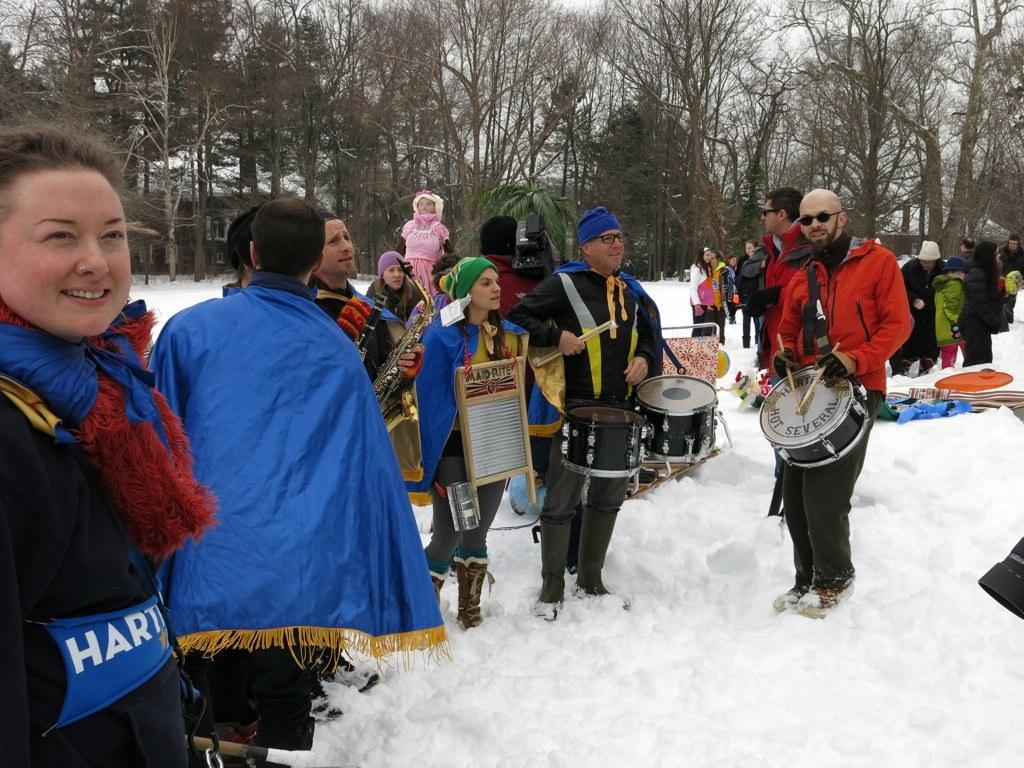<image>
Create a compact narrative representing the image presented. Many people are standing in the snow, including one man who holds a drum reading Hartford Hot Several. 